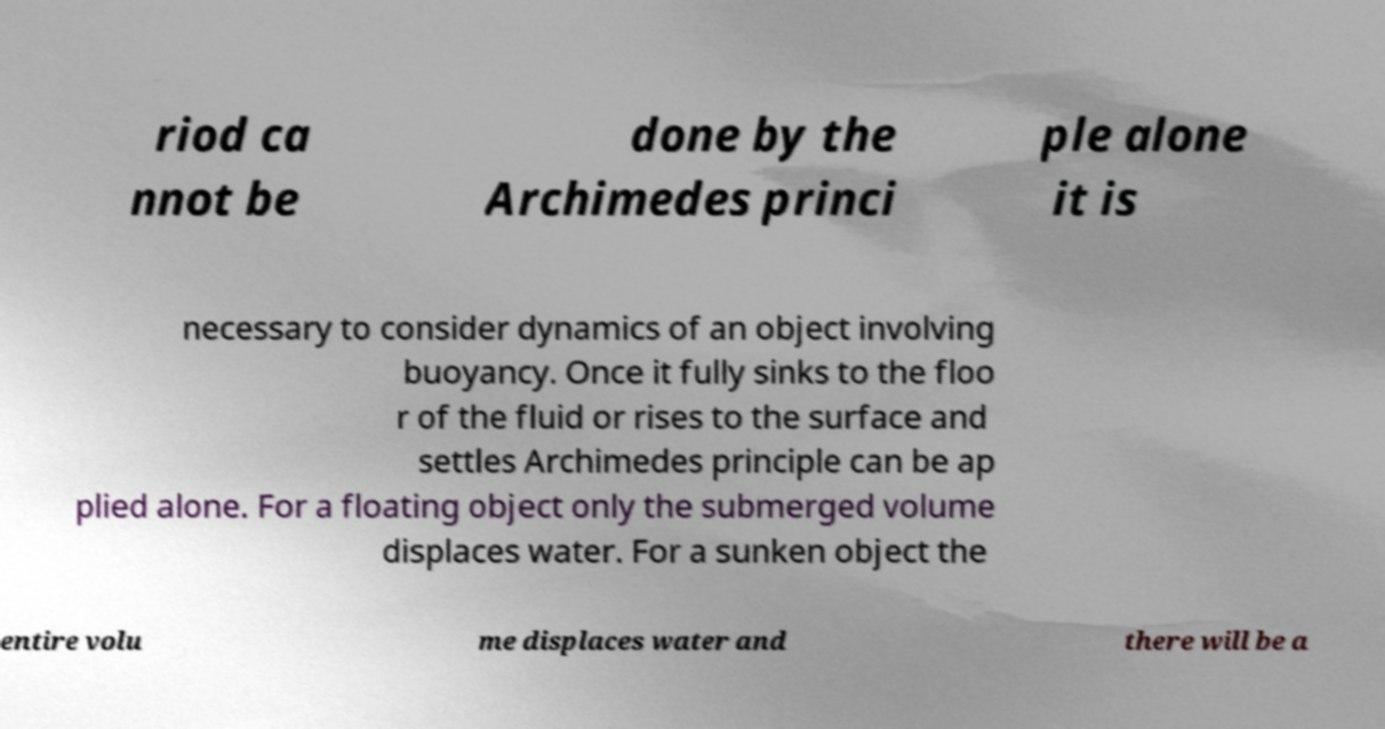For documentation purposes, I need the text within this image transcribed. Could you provide that? riod ca nnot be done by the Archimedes princi ple alone it is necessary to consider dynamics of an object involving buoyancy. Once it fully sinks to the floo r of the fluid or rises to the surface and settles Archimedes principle can be ap plied alone. For a floating object only the submerged volume displaces water. For a sunken object the entire volu me displaces water and there will be a 